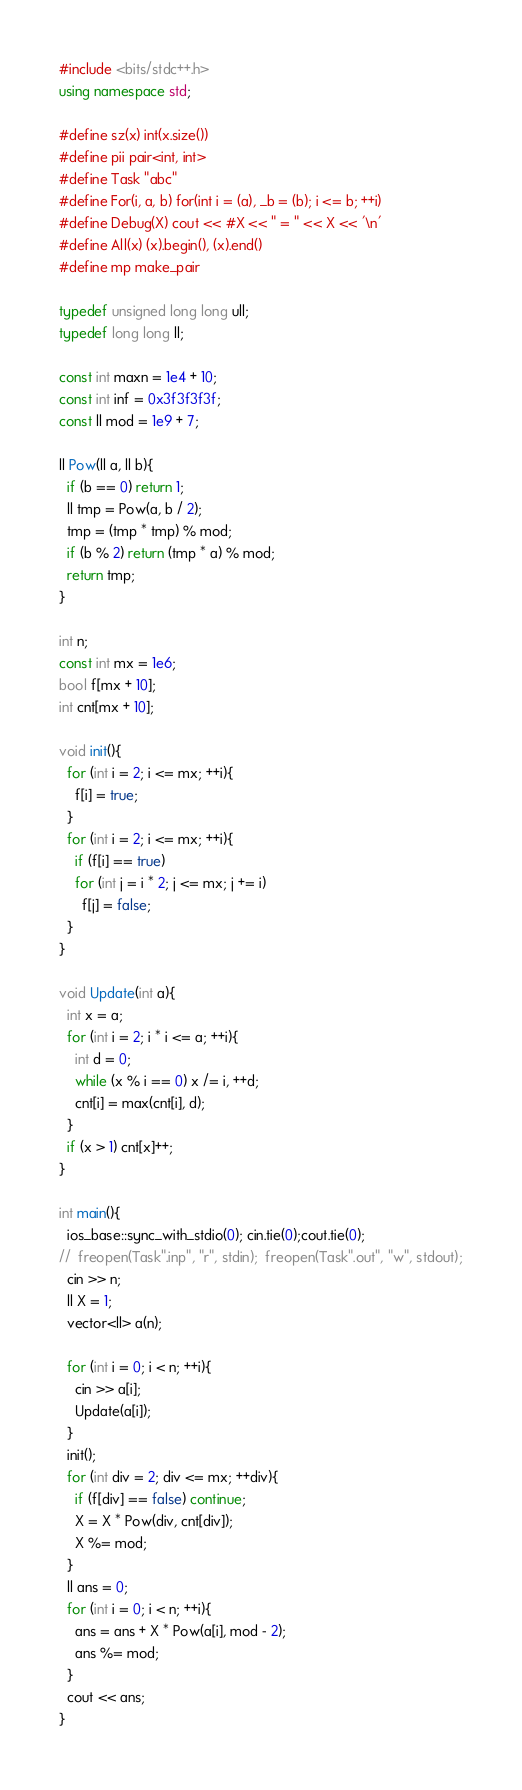<code> <loc_0><loc_0><loc_500><loc_500><_C++_>#include <bits/stdc++.h>
using namespace std;

#define sz(x) int(x.size())
#define pii pair<int, int>
#define Task "abc"
#define For(i, a, b) for(int i = (a), _b = (b); i <= b; ++i)
#define Debug(X) cout << #X << " = " << X << '\n'
#define All(x) (x).begin(), (x).end()
#define mp make_pair

typedef unsigned long long ull;
typedef long long ll;

const int maxn = 1e4 + 10;
const int inf = 0x3f3f3f3f;
const ll mod = 1e9 + 7;

ll Pow(ll a, ll b){
  if (b == 0) return 1;
  ll tmp = Pow(a, b / 2);
  tmp = (tmp * tmp) % mod;
  if (b % 2) return (tmp * a) % mod;
  return tmp;
}

int n;
const int mx = 1e6;
bool f[mx + 10];
int cnt[mx + 10];

void init(){
  for (int i = 2; i <= mx; ++i){
    f[i] = true;
  }
  for (int i = 2; i <= mx; ++i){
    if (f[i] == true)
    for (int j = i * 2; j <= mx; j += i)
      f[j] = false;
  }
}

void Update(int a){
  int x = a;
  for (int i = 2; i * i <= a; ++i){
    int d = 0;
    while (x % i == 0) x /= i, ++d;
    cnt[i] = max(cnt[i], d);
  }
  if (x > 1) cnt[x]++;
}

int main(){
  ios_base::sync_with_stdio(0); cin.tie(0);cout.tie(0);
//  freopen(Task".inp", "r", stdin);  freopen(Task".out", "w", stdout);
  cin >> n;
  ll X = 1;
  vector<ll> a(n);

  for (int i = 0; i < n; ++i){
    cin >> a[i];
    Update(a[i]);
  }
  init();
  for (int div = 2; div <= mx; ++div){
    if (f[div] == false) continue;
    X = X * Pow(div, cnt[div]);
    X %= mod;
  }
  ll ans = 0;
  for (int i = 0; i < n; ++i){
    ans = ans + X * Pow(a[i], mod - 2);
    ans %= mod;
  }
  cout << ans;
}


</code> 